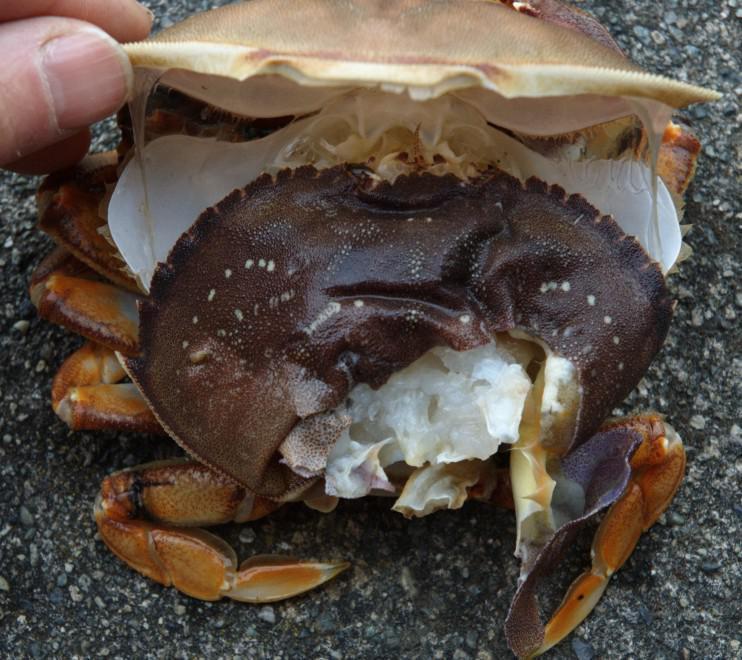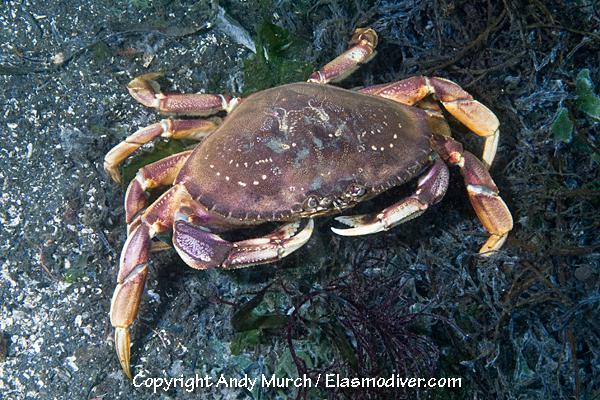The first image is the image on the left, the second image is the image on the right. Considering the images on both sides, is "Some of the crabs are in a net." valid? Answer yes or no. No. The first image is the image on the left, the second image is the image on the right. Analyze the images presented: Is the assertion "At least part of an ungloved hand is seen in the left image." valid? Answer yes or no. Yes. 